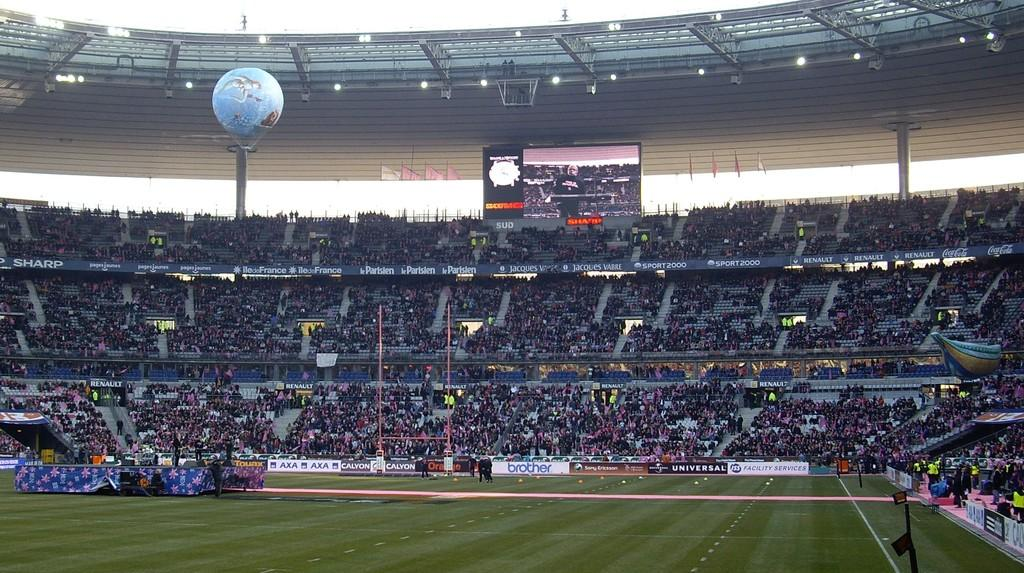What type of surface can be seen in the image? There is ground visible in the image. What structures are present in the image? There are hoardings, poles, a screen, and pillars in the image. What objects are in the image? There is cloth, chairs, a parachute, lights, and steps in the image. What else can be seen in the image? There is a roof, flags, and people in the image. What is visible in the background of the image? The sky is visible in the background of the image. What type of conversation is taking place in the church in the image? There is no church present in the image, and therefore no conversation can be observed. 